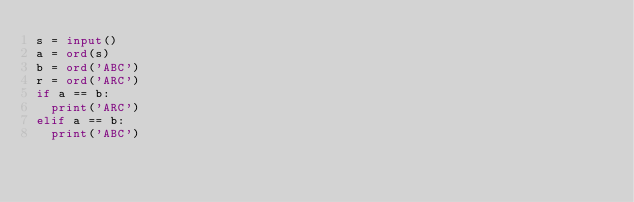Convert code to text. <code><loc_0><loc_0><loc_500><loc_500><_Python_>s = input()
a = ord(s)
b = ord('ABC')
r = ord('ARC')
if a == b:
  print('ARC')
elif a == b:
  print('ABC')</code> 